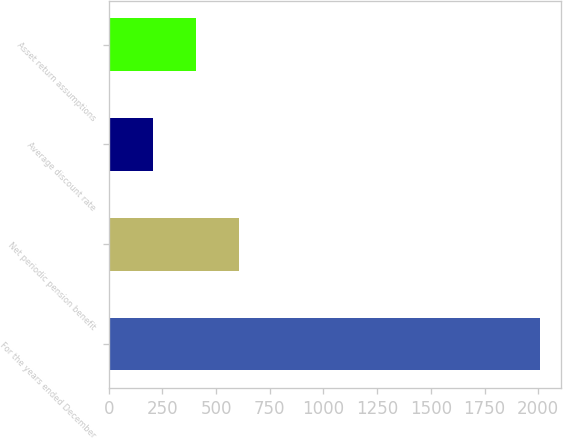<chart> <loc_0><loc_0><loc_500><loc_500><bar_chart><fcel>For the years ended December<fcel>Net periodic pension benefit<fcel>Average discount rate<fcel>Asset return assumptions<nl><fcel>2007<fcel>606.16<fcel>205.92<fcel>406.04<nl></chart> 